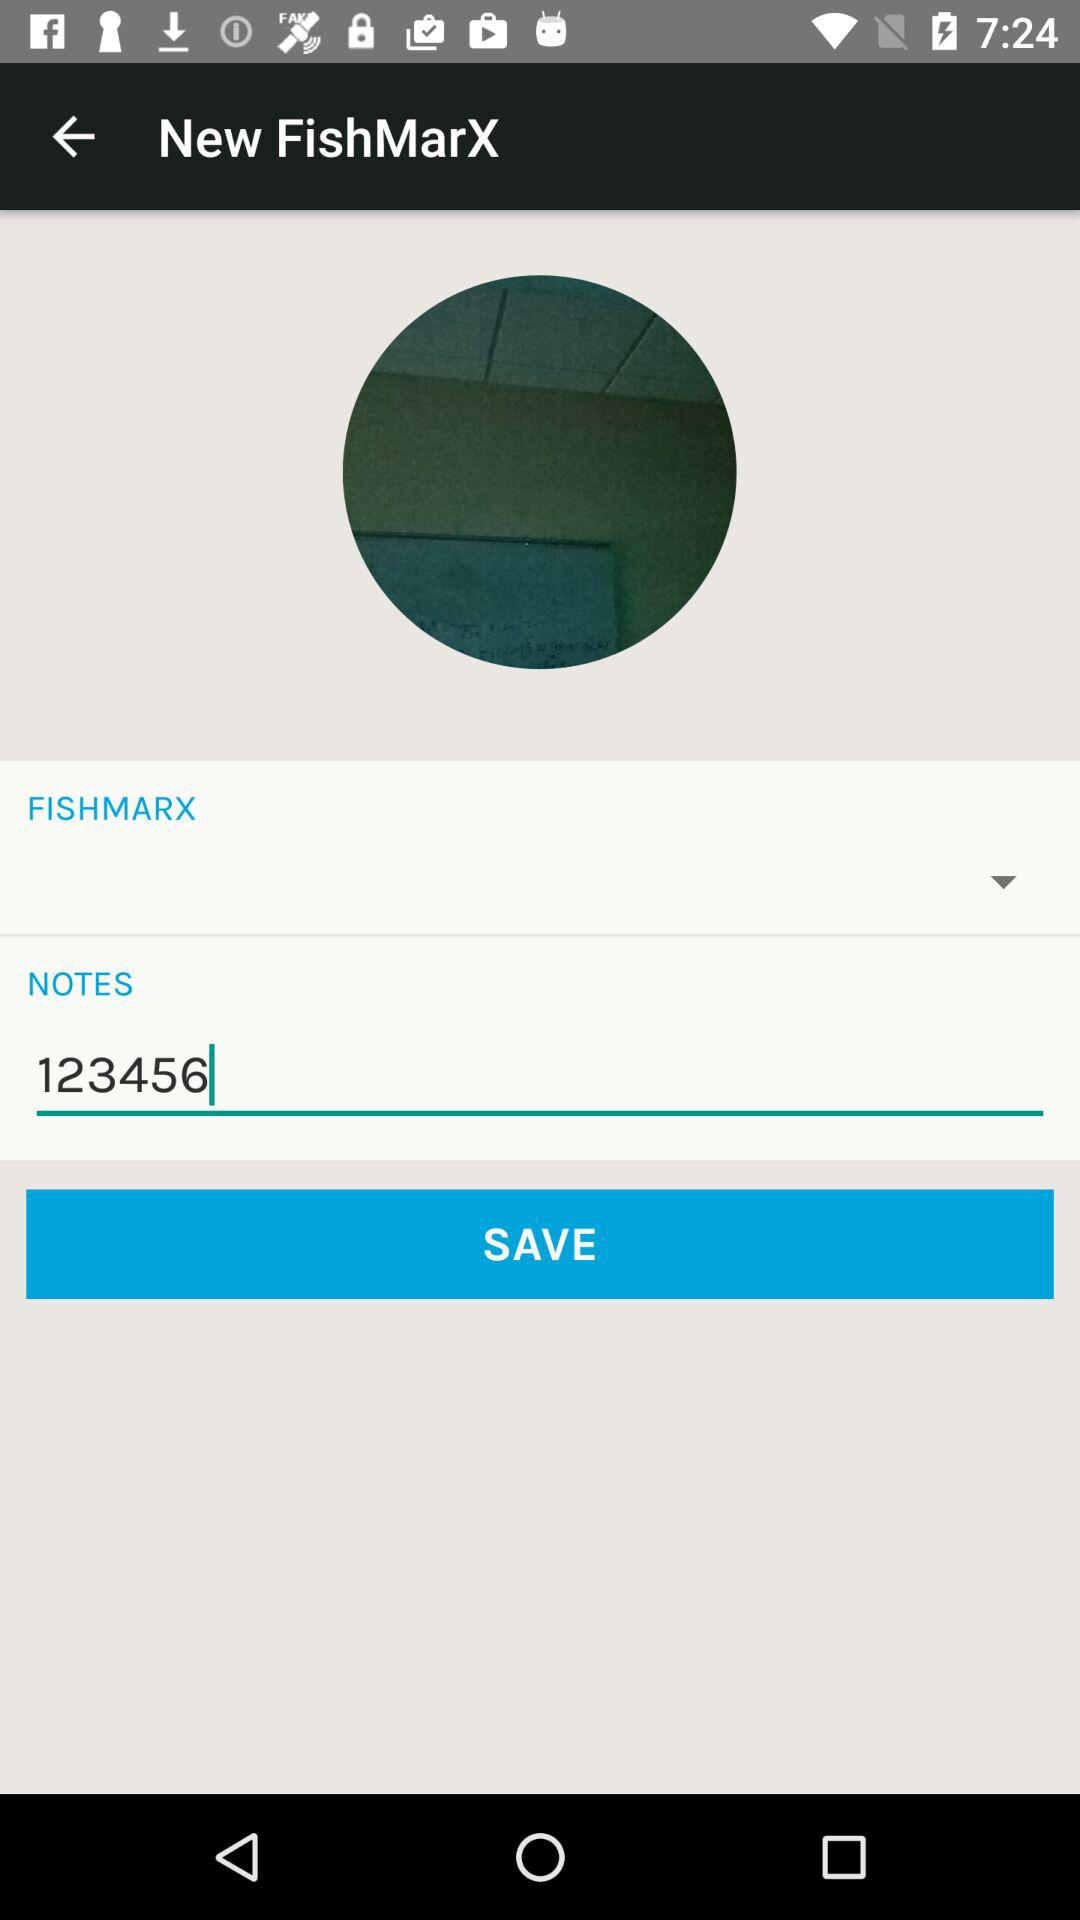What is the selected number in the "NOTES"? The selected number in the "NOTES" is 123456. 